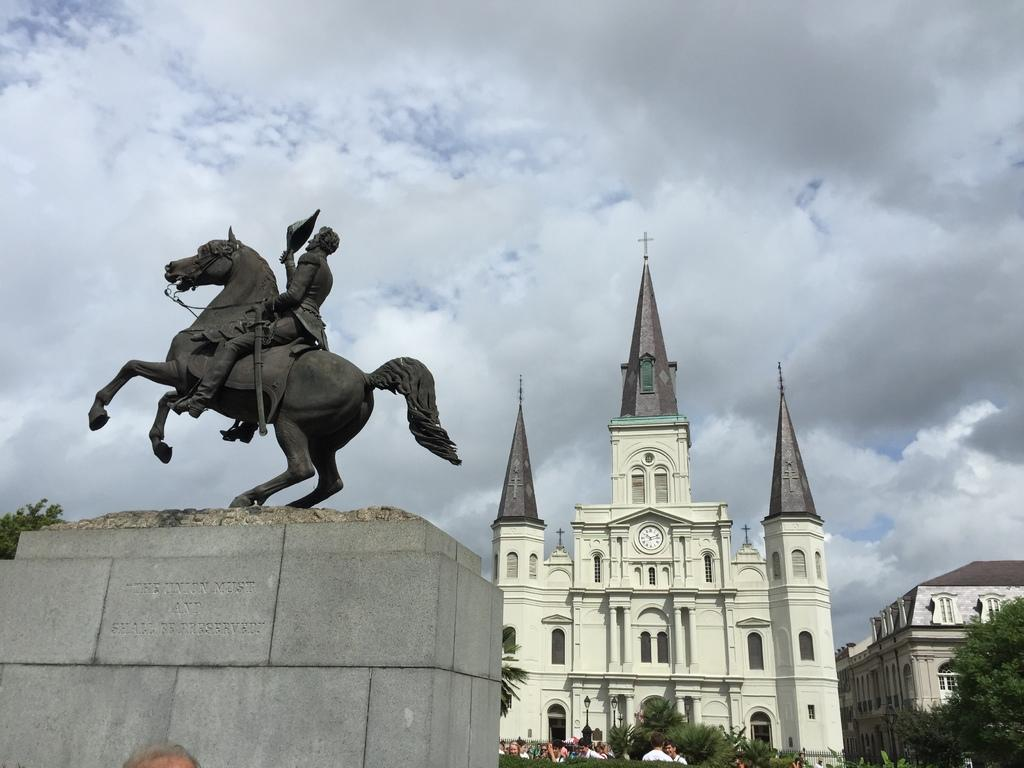What is the main subject of the image? There is a statue in the image. What is the statue resting on? The statue is on an object. What can be seen in the background of the image? There are buildings, people, trees, and the sky visible in the background of the image. How would you describe the sky in the image? The sky appears to be cloudy in the image. Can you see any deer or honey in the image? No, there are no deer or honey present in the image. What type of ray is swimming near the statue in the image? There is no ray present in the image; it features a statue and various background elements. 